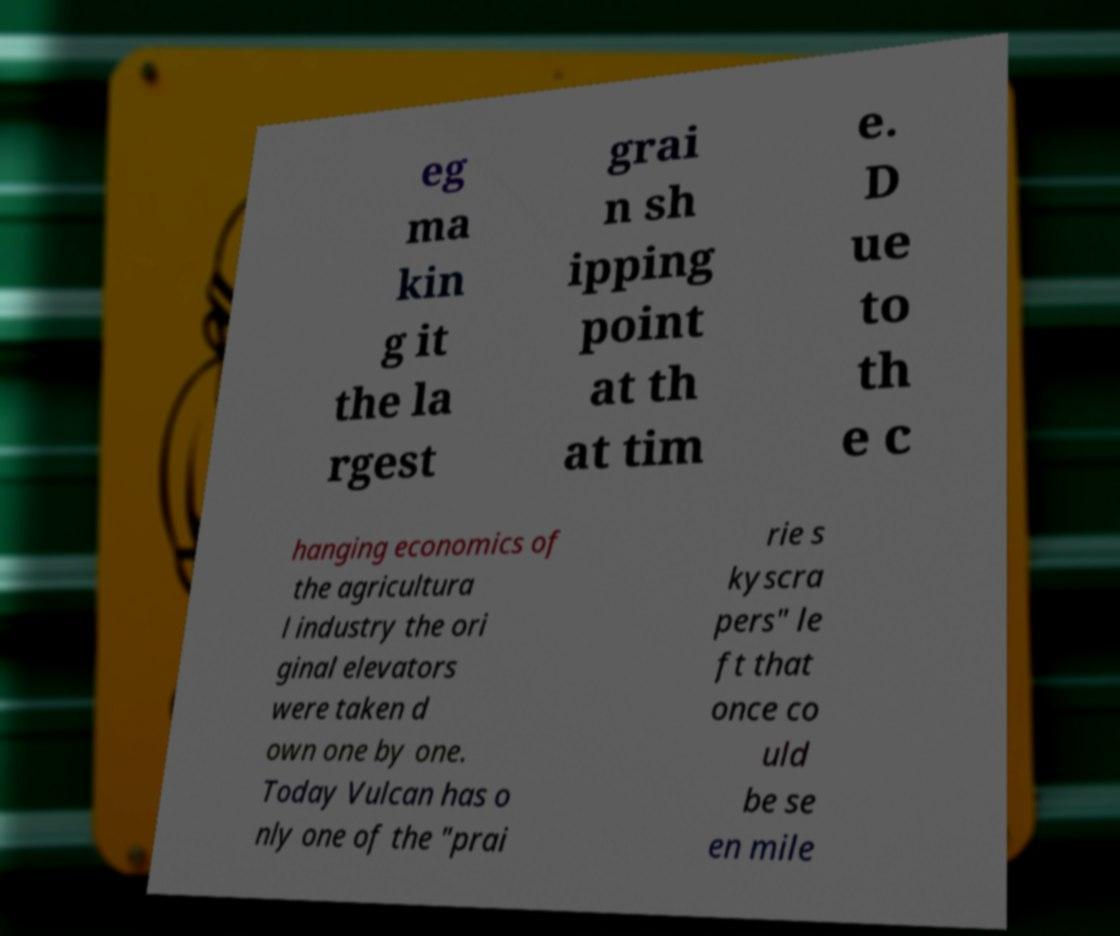For documentation purposes, I need the text within this image transcribed. Could you provide that? eg ma kin g it the la rgest grai n sh ipping point at th at tim e. D ue to th e c hanging economics of the agricultura l industry the ori ginal elevators were taken d own one by one. Today Vulcan has o nly one of the "prai rie s kyscra pers" le ft that once co uld be se en mile 